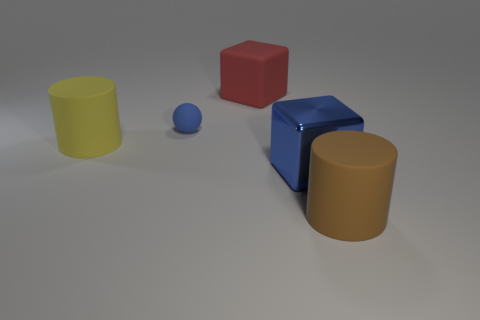Does the blue thing in front of the yellow object have the same size as the large brown rubber thing?
Provide a short and direct response. Yes. Are there fewer big matte cubes than cyan rubber cylinders?
Give a very brief answer. No. There is a small thing behind the large cylinder that is on the left side of the cube behind the small blue thing; what shape is it?
Offer a terse response. Sphere. Is there a big thing made of the same material as the small sphere?
Give a very brief answer. Yes. Does the rubber cylinder that is left of the large metal thing have the same color as the thing behind the small blue object?
Give a very brief answer. No. Are there fewer shiny objects that are to the right of the large blue thing than blue balls?
Offer a very short reply. Yes. What number of objects are either large blue rubber things or things right of the tiny matte thing?
Your response must be concise. 3. There is a small ball that is made of the same material as the red cube; what color is it?
Your answer should be compact. Blue. How many objects are red things or small cyan shiny cylinders?
Your answer should be compact. 1. What color is the other block that is the same size as the shiny cube?
Give a very brief answer. Red. 